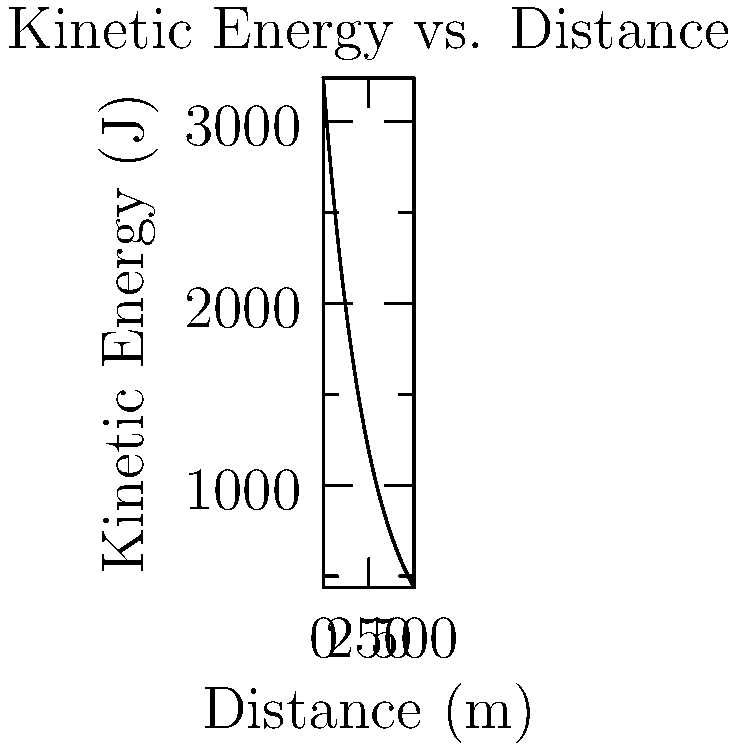A 7.62x51mm NATO round weighing 8 grams is fired from a rifle with an initial velocity of 900 m/s. The bullet's velocity $v$ (in m/s) at a distance $x$ (in meters) from the muzzle can be modeled by the equation $v(x) = 900e^{-0.002x}$. Given that the kinetic energy of a bullet is $KE = \frac{1}{2}mv^2$, where $m$ is the mass in kg, find the rate of change of the bullet's kinetic energy with respect to distance when the bullet has traveled 200 meters. Let's approach this step-by-step:

1) First, we need to express the kinetic energy as a function of distance:
   $KE(x) = \frac{1}{2}m(v(x))^2 = \frac{1}{2}(0.008)(900e^{-0.002x})^2$

2) Simplify:
   $KE(x) = 3240e^{-0.004x}$

3) To find the rate of change, we need to differentiate $KE(x)$ with respect to x:
   $\frac{d}{dx}KE(x) = 3240 \cdot (-0.004)e^{-0.004x} = -12.96e^{-0.004x}$

4) Now, we need to evaluate this at x = 200:
   $\frac{d}{dx}KE(200) = -12.96e^{-0.004(200)} = -12.96e^{-0.8}$

5) Calculate:
   $\frac{d}{dx}KE(200) \approx -5.82$ J/m

The negative sign indicates that the kinetic energy is decreasing as the bullet travels further.
Answer: $-5.82$ J/m 